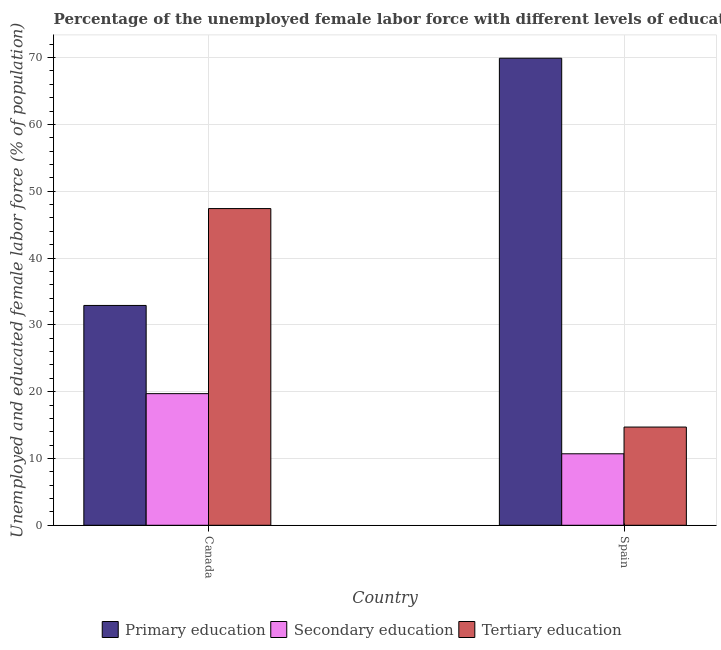How many groups of bars are there?
Provide a succinct answer. 2. Are the number of bars per tick equal to the number of legend labels?
Keep it short and to the point. Yes. How many bars are there on the 1st tick from the left?
Make the answer very short. 3. What is the percentage of female labor force who received primary education in Canada?
Your response must be concise. 32.9. Across all countries, what is the maximum percentage of female labor force who received primary education?
Provide a short and direct response. 69.9. Across all countries, what is the minimum percentage of female labor force who received secondary education?
Make the answer very short. 10.7. In which country was the percentage of female labor force who received tertiary education maximum?
Offer a terse response. Canada. What is the total percentage of female labor force who received secondary education in the graph?
Your answer should be compact. 30.4. What is the difference between the percentage of female labor force who received primary education in Canada and that in Spain?
Ensure brevity in your answer.  -37. What is the difference between the percentage of female labor force who received tertiary education in Canada and the percentage of female labor force who received secondary education in Spain?
Offer a terse response. 36.7. What is the average percentage of female labor force who received primary education per country?
Give a very brief answer. 51.4. What is the difference between the percentage of female labor force who received primary education and percentage of female labor force who received tertiary education in Canada?
Your answer should be compact. -14.5. In how many countries, is the percentage of female labor force who received primary education greater than 60 %?
Offer a very short reply. 1. What is the ratio of the percentage of female labor force who received secondary education in Canada to that in Spain?
Your answer should be compact. 1.84. What does the 3rd bar from the left in Canada represents?
Make the answer very short. Tertiary education. What does the 2nd bar from the right in Spain represents?
Keep it short and to the point. Secondary education. How many bars are there?
Offer a very short reply. 6. How many countries are there in the graph?
Keep it short and to the point. 2. What is the difference between two consecutive major ticks on the Y-axis?
Make the answer very short. 10. Are the values on the major ticks of Y-axis written in scientific E-notation?
Your answer should be compact. No. Does the graph contain any zero values?
Give a very brief answer. No. Does the graph contain grids?
Keep it short and to the point. Yes. Where does the legend appear in the graph?
Give a very brief answer. Bottom center. How many legend labels are there?
Keep it short and to the point. 3. How are the legend labels stacked?
Make the answer very short. Horizontal. What is the title of the graph?
Provide a short and direct response. Percentage of the unemployed female labor force with different levels of education in countries. Does "Secondary" appear as one of the legend labels in the graph?
Provide a succinct answer. No. What is the label or title of the Y-axis?
Offer a very short reply. Unemployed and educated female labor force (% of population). What is the Unemployed and educated female labor force (% of population) of Primary education in Canada?
Make the answer very short. 32.9. What is the Unemployed and educated female labor force (% of population) in Secondary education in Canada?
Give a very brief answer. 19.7. What is the Unemployed and educated female labor force (% of population) in Tertiary education in Canada?
Your response must be concise. 47.4. What is the Unemployed and educated female labor force (% of population) in Primary education in Spain?
Ensure brevity in your answer.  69.9. What is the Unemployed and educated female labor force (% of population) of Secondary education in Spain?
Give a very brief answer. 10.7. What is the Unemployed and educated female labor force (% of population) in Tertiary education in Spain?
Provide a short and direct response. 14.7. Across all countries, what is the maximum Unemployed and educated female labor force (% of population) of Primary education?
Your answer should be very brief. 69.9. Across all countries, what is the maximum Unemployed and educated female labor force (% of population) of Secondary education?
Make the answer very short. 19.7. Across all countries, what is the maximum Unemployed and educated female labor force (% of population) in Tertiary education?
Provide a short and direct response. 47.4. Across all countries, what is the minimum Unemployed and educated female labor force (% of population) in Primary education?
Offer a terse response. 32.9. Across all countries, what is the minimum Unemployed and educated female labor force (% of population) in Secondary education?
Offer a very short reply. 10.7. Across all countries, what is the minimum Unemployed and educated female labor force (% of population) of Tertiary education?
Make the answer very short. 14.7. What is the total Unemployed and educated female labor force (% of population) in Primary education in the graph?
Offer a very short reply. 102.8. What is the total Unemployed and educated female labor force (% of population) in Secondary education in the graph?
Your response must be concise. 30.4. What is the total Unemployed and educated female labor force (% of population) in Tertiary education in the graph?
Offer a very short reply. 62.1. What is the difference between the Unemployed and educated female labor force (% of population) in Primary education in Canada and that in Spain?
Provide a succinct answer. -37. What is the difference between the Unemployed and educated female labor force (% of population) in Secondary education in Canada and that in Spain?
Your answer should be very brief. 9. What is the difference between the Unemployed and educated female labor force (% of population) of Tertiary education in Canada and that in Spain?
Your answer should be very brief. 32.7. What is the difference between the Unemployed and educated female labor force (% of population) of Primary education in Canada and the Unemployed and educated female labor force (% of population) of Tertiary education in Spain?
Your answer should be very brief. 18.2. What is the difference between the Unemployed and educated female labor force (% of population) in Secondary education in Canada and the Unemployed and educated female labor force (% of population) in Tertiary education in Spain?
Keep it short and to the point. 5. What is the average Unemployed and educated female labor force (% of population) in Primary education per country?
Provide a short and direct response. 51.4. What is the average Unemployed and educated female labor force (% of population) in Tertiary education per country?
Offer a terse response. 31.05. What is the difference between the Unemployed and educated female labor force (% of population) of Primary education and Unemployed and educated female labor force (% of population) of Secondary education in Canada?
Your response must be concise. 13.2. What is the difference between the Unemployed and educated female labor force (% of population) of Secondary education and Unemployed and educated female labor force (% of population) of Tertiary education in Canada?
Your response must be concise. -27.7. What is the difference between the Unemployed and educated female labor force (% of population) in Primary education and Unemployed and educated female labor force (% of population) in Secondary education in Spain?
Provide a short and direct response. 59.2. What is the difference between the Unemployed and educated female labor force (% of population) of Primary education and Unemployed and educated female labor force (% of population) of Tertiary education in Spain?
Your answer should be compact. 55.2. What is the ratio of the Unemployed and educated female labor force (% of population) in Primary education in Canada to that in Spain?
Ensure brevity in your answer.  0.47. What is the ratio of the Unemployed and educated female labor force (% of population) in Secondary education in Canada to that in Spain?
Your answer should be very brief. 1.84. What is the ratio of the Unemployed and educated female labor force (% of population) of Tertiary education in Canada to that in Spain?
Offer a terse response. 3.22. What is the difference between the highest and the second highest Unemployed and educated female labor force (% of population) of Secondary education?
Your answer should be very brief. 9. What is the difference between the highest and the second highest Unemployed and educated female labor force (% of population) of Tertiary education?
Your response must be concise. 32.7. What is the difference between the highest and the lowest Unemployed and educated female labor force (% of population) of Primary education?
Make the answer very short. 37. What is the difference between the highest and the lowest Unemployed and educated female labor force (% of population) in Tertiary education?
Provide a succinct answer. 32.7. 